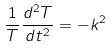<formula> <loc_0><loc_0><loc_500><loc_500>\frac { 1 } { T } \frac { d ^ { 2 } T } { d t ^ { 2 } } = - k ^ { 2 }</formula> 